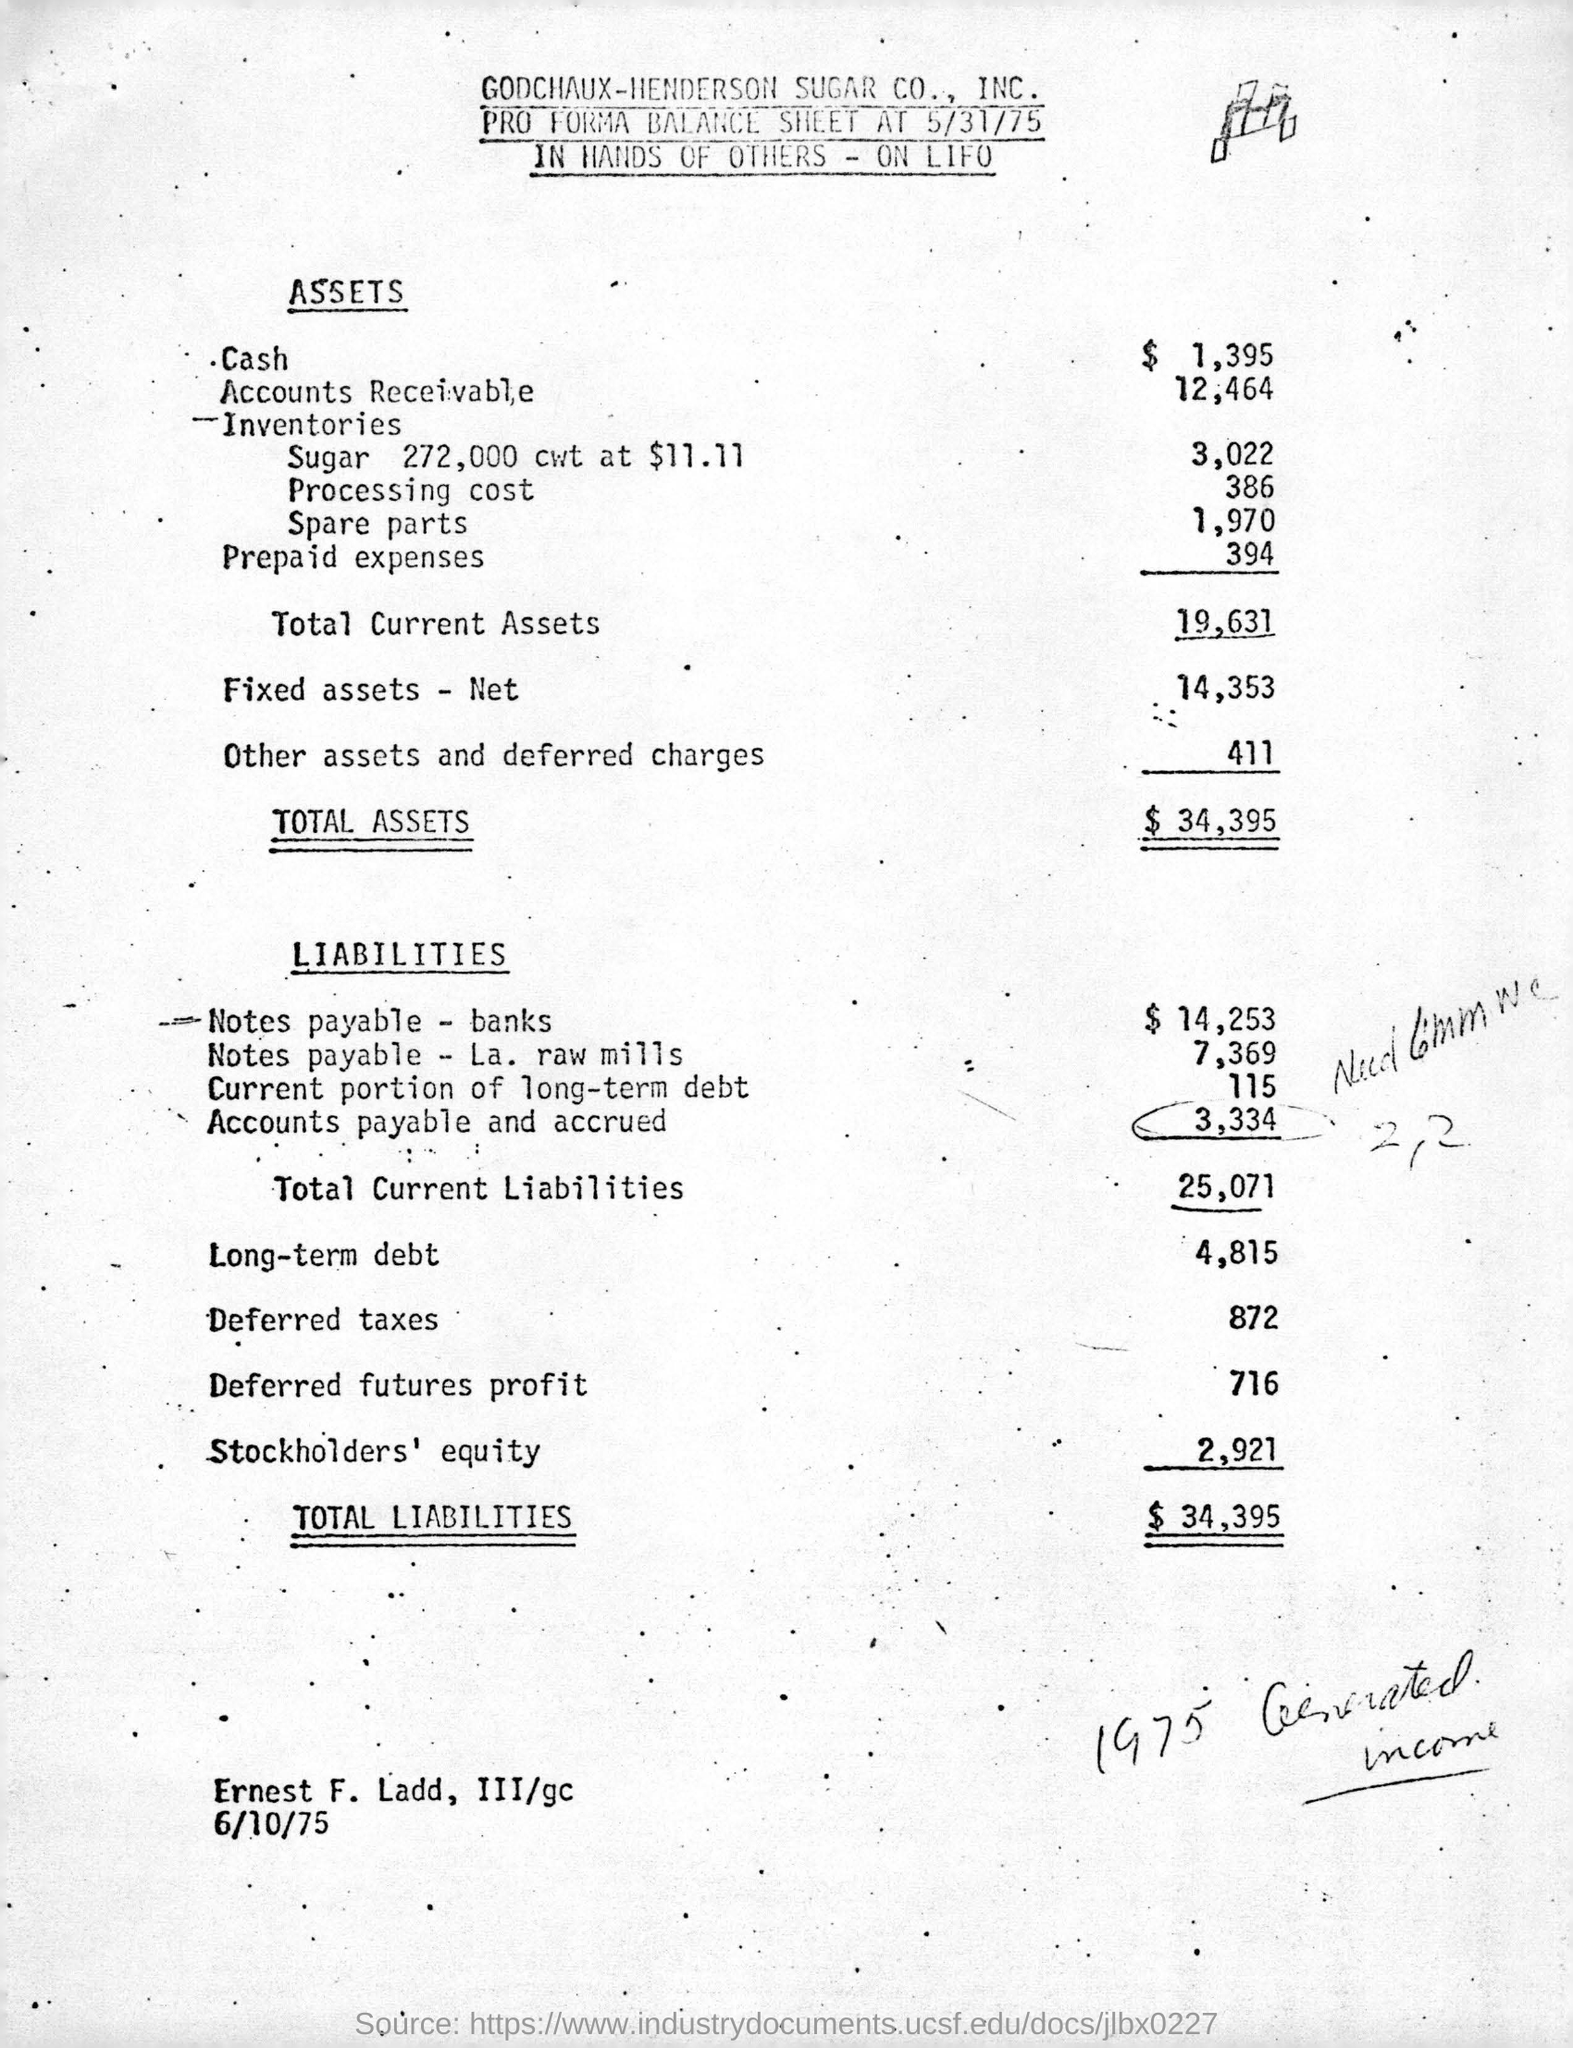Draw attention to some important aspects in this diagram. Total assets in dollars are $34,395. The balance sheet of GODCHAUX-HENDERSON SUGAR CO., INC. is given here. Total current liabilities are 25,071. 